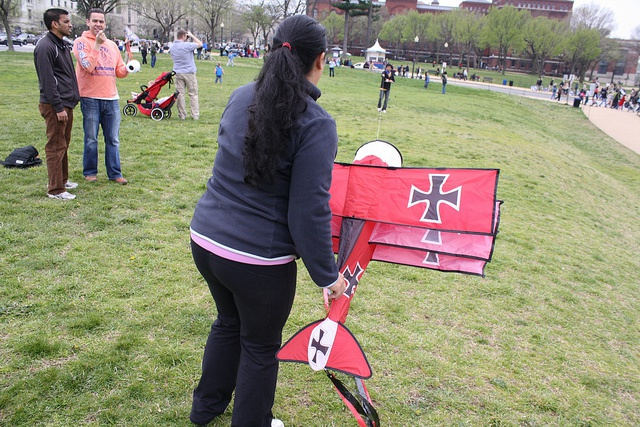Describe the objects in this image and their specific colors. I can see people in gray, black, and purple tones, kite in gray, salmon, lavender, and purple tones, people in gray, lightpink, navy, and pink tones, people in gray, black, and maroon tones, and people in gray, darkgray, lightgray, and olive tones in this image. 